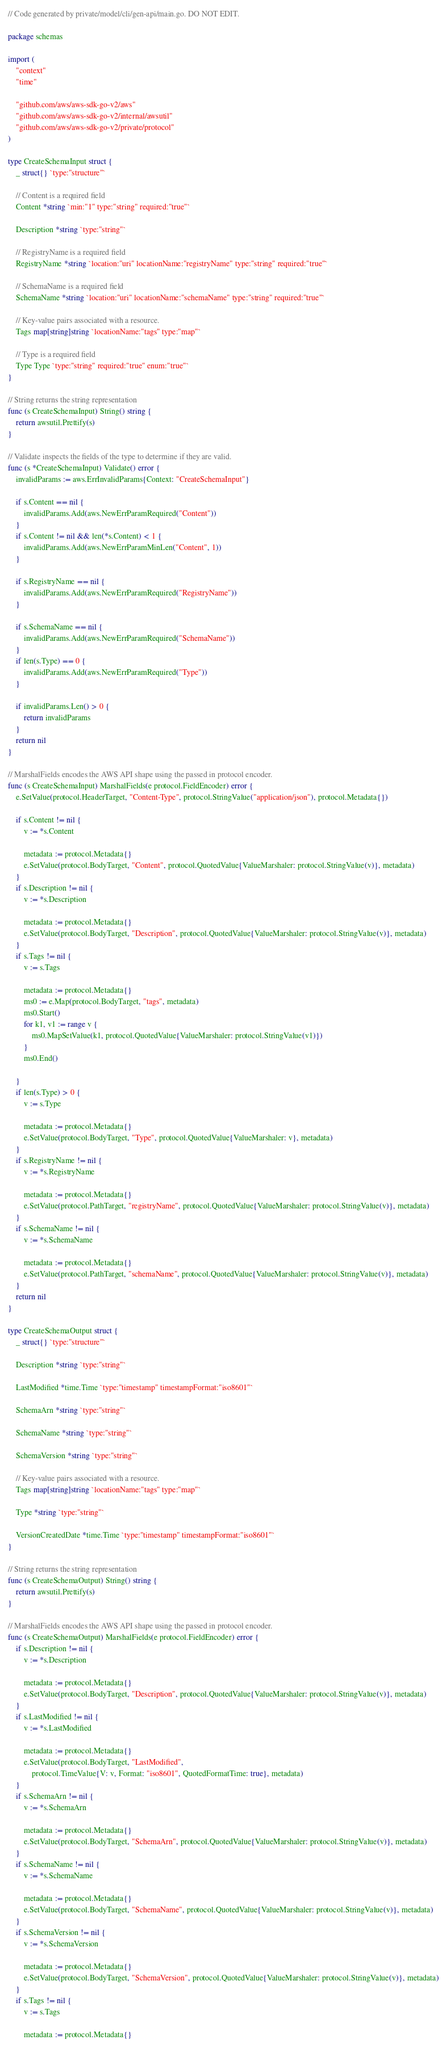Convert code to text. <code><loc_0><loc_0><loc_500><loc_500><_Go_>// Code generated by private/model/cli/gen-api/main.go. DO NOT EDIT.

package schemas

import (
	"context"
	"time"

	"github.com/aws/aws-sdk-go-v2/aws"
	"github.com/aws/aws-sdk-go-v2/internal/awsutil"
	"github.com/aws/aws-sdk-go-v2/private/protocol"
)

type CreateSchemaInput struct {
	_ struct{} `type:"structure"`

	// Content is a required field
	Content *string `min:"1" type:"string" required:"true"`

	Description *string `type:"string"`

	// RegistryName is a required field
	RegistryName *string `location:"uri" locationName:"registryName" type:"string" required:"true"`

	// SchemaName is a required field
	SchemaName *string `location:"uri" locationName:"schemaName" type:"string" required:"true"`

	// Key-value pairs associated with a resource.
	Tags map[string]string `locationName:"tags" type:"map"`

	// Type is a required field
	Type Type `type:"string" required:"true" enum:"true"`
}

// String returns the string representation
func (s CreateSchemaInput) String() string {
	return awsutil.Prettify(s)
}

// Validate inspects the fields of the type to determine if they are valid.
func (s *CreateSchemaInput) Validate() error {
	invalidParams := aws.ErrInvalidParams{Context: "CreateSchemaInput"}

	if s.Content == nil {
		invalidParams.Add(aws.NewErrParamRequired("Content"))
	}
	if s.Content != nil && len(*s.Content) < 1 {
		invalidParams.Add(aws.NewErrParamMinLen("Content", 1))
	}

	if s.RegistryName == nil {
		invalidParams.Add(aws.NewErrParamRequired("RegistryName"))
	}

	if s.SchemaName == nil {
		invalidParams.Add(aws.NewErrParamRequired("SchemaName"))
	}
	if len(s.Type) == 0 {
		invalidParams.Add(aws.NewErrParamRequired("Type"))
	}

	if invalidParams.Len() > 0 {
		return invalidParams
	}
	return nil
}

// MarshalFields encodes the AWS API shape using the passed in protocol encoder.
func (s CreateSchemaInput) MarshalFields(e protocol.FieldEncoder) error {
	e.SetValue(protocol.HeaderTarget, "Content-Type", protocol.StringValue("application/json"), protocol.Metadata{})

	if s.Content != nil {
		v := *s.Content

		metadata := protocol.Metadata{}
		e.SetValue(protocol.BodyTarget, "Content", protocol.QuotedValue{ValueMarshaler: protocol.StringValue(v)}, metadata)
	}
	if s.Description != nil {
		v := *s.Description

		metadata := protocol.Metadata{}
		e.SetValue(protocol.BodyTarget, "Description", protocol.QuotedValue{ValueMarshaler: protocol.StringValue(v)}, metadata)
	}
	if s.Tags != nil {
		v := s.Tags

		metadata := protocol.Metadata{}
		ms0 := e.Map(protocol.BodyTarget, "tags", metadata)
		ms0.Start()
		for k1, v1 := range v {
			ms0.MapSetValue(k1, protocol.QuotedValue{ValueMarshaler: protocol.StringValue(v1)})
		}
		ms0.End()

	}
	if len(s.Type) > 0 {
		v := s.Type

		metadata := protocol.Metadata{}
		e.SetValue(protocol.BodyTarget, "Type", protocol.QuotedValue{ValueMarshaler: v}, metadata)
	}
	if s.RegistryName != nil {
		v := *s.RegistryName

		metadata := protocol.Metadata{}
		e.SetValue(protocol.PathTarget, "registryName", protocol.QuotedValue{ValueMarshaler: protocol.StringValue(v)}, metadata)
	}
	if s.SchemaName != nil {
		v := *s.SchemaName

		metadata := protocol.Metadata{}
		e.SetValue(protocol.PathTarget, "schemaName", protocol.QuotedValue{ValueMarshaler: protocol.StringValue(v)}, metadata)
	}
	return nil
}

type CreateSchemaOutput struct {
	_ struct{} `type:"structure"`

	Description *string `type:"string"`

	LastModified *time.Time `type:"timestamp" timestampFormat:"iso8601"`

	SchemaArn *string `type:"string"`

	SchemaName *string `type:"string"`

	SchemaVersion *string `type:"string"`

	// Key-value pairs associated with a resource.
	Tags map[string]string `locationName:"tags" type:"map"`

	Type *string `type:"string"`

	VersionCreatedDate *time.Time `type:"timestamp" timestampFormat:"iso8601"`
}

// String returns the string representation
func (s CreateSchemaOutput) String() string {
	return awsutil.Prettify(s)
}

// MarshalFields encodes the AWS API shape using the passed in protocol encoder.
func (s CreateSchemaOutput) MarshalFields(e protocol.FieldEncoder) error {
	if s.Description != nil {
		v := *s.Description

		metadata := protocol.Metadata{}
		e.SetValue(protocol.BodyTarget, "Description", protocol.QuotedValue{ValueMarshaler: protocol.StringValue(v)}, metadata)
	}
	if s.LastModified != nil {
		v := *s.LastModified

		metadata := protocol.Metadata{}
		e.SetValue(protocol.BodyTarget, "LastModified",
			protocol.TimeValue{V: v, Format: "iso8601", QuotedFormatTime: true}, metadata)
	}
	if s.SchemaArn != nil {
		v := *s.SchemaArn

		metadata := protocol.Metadata{}
		e.SetValue(protocol.BodyTarget, "SchemaArn", protocol.QuotedValue{ValueMarshaler: protocol.StringValue(v)}, metadata)
	}
	if s.SchemaName != nil {
		v := *s.SchemaName

		metadata := protocol.Metadata{}
		e.SetValue(protocol.BodyTarget, "SchemaName", protocol.QuotedValue{ValueMarshaler: protocol.StringValue(v)}, metadata)
	}
	if s.SchemaVersion != nil {
		v := *s.SchemaVersion

		metadata := protocol.Metadata{}
		e.SetValue(protocol.BodyTarget, "SchemaVersion", protocol.QuotedValue{ValueMarshaler: protocol.StringValue(v)}, metadata)
	}
	if s.Tags != nil {
		v := s.Tags

		metadata := protocol.Metadata{}</code> 